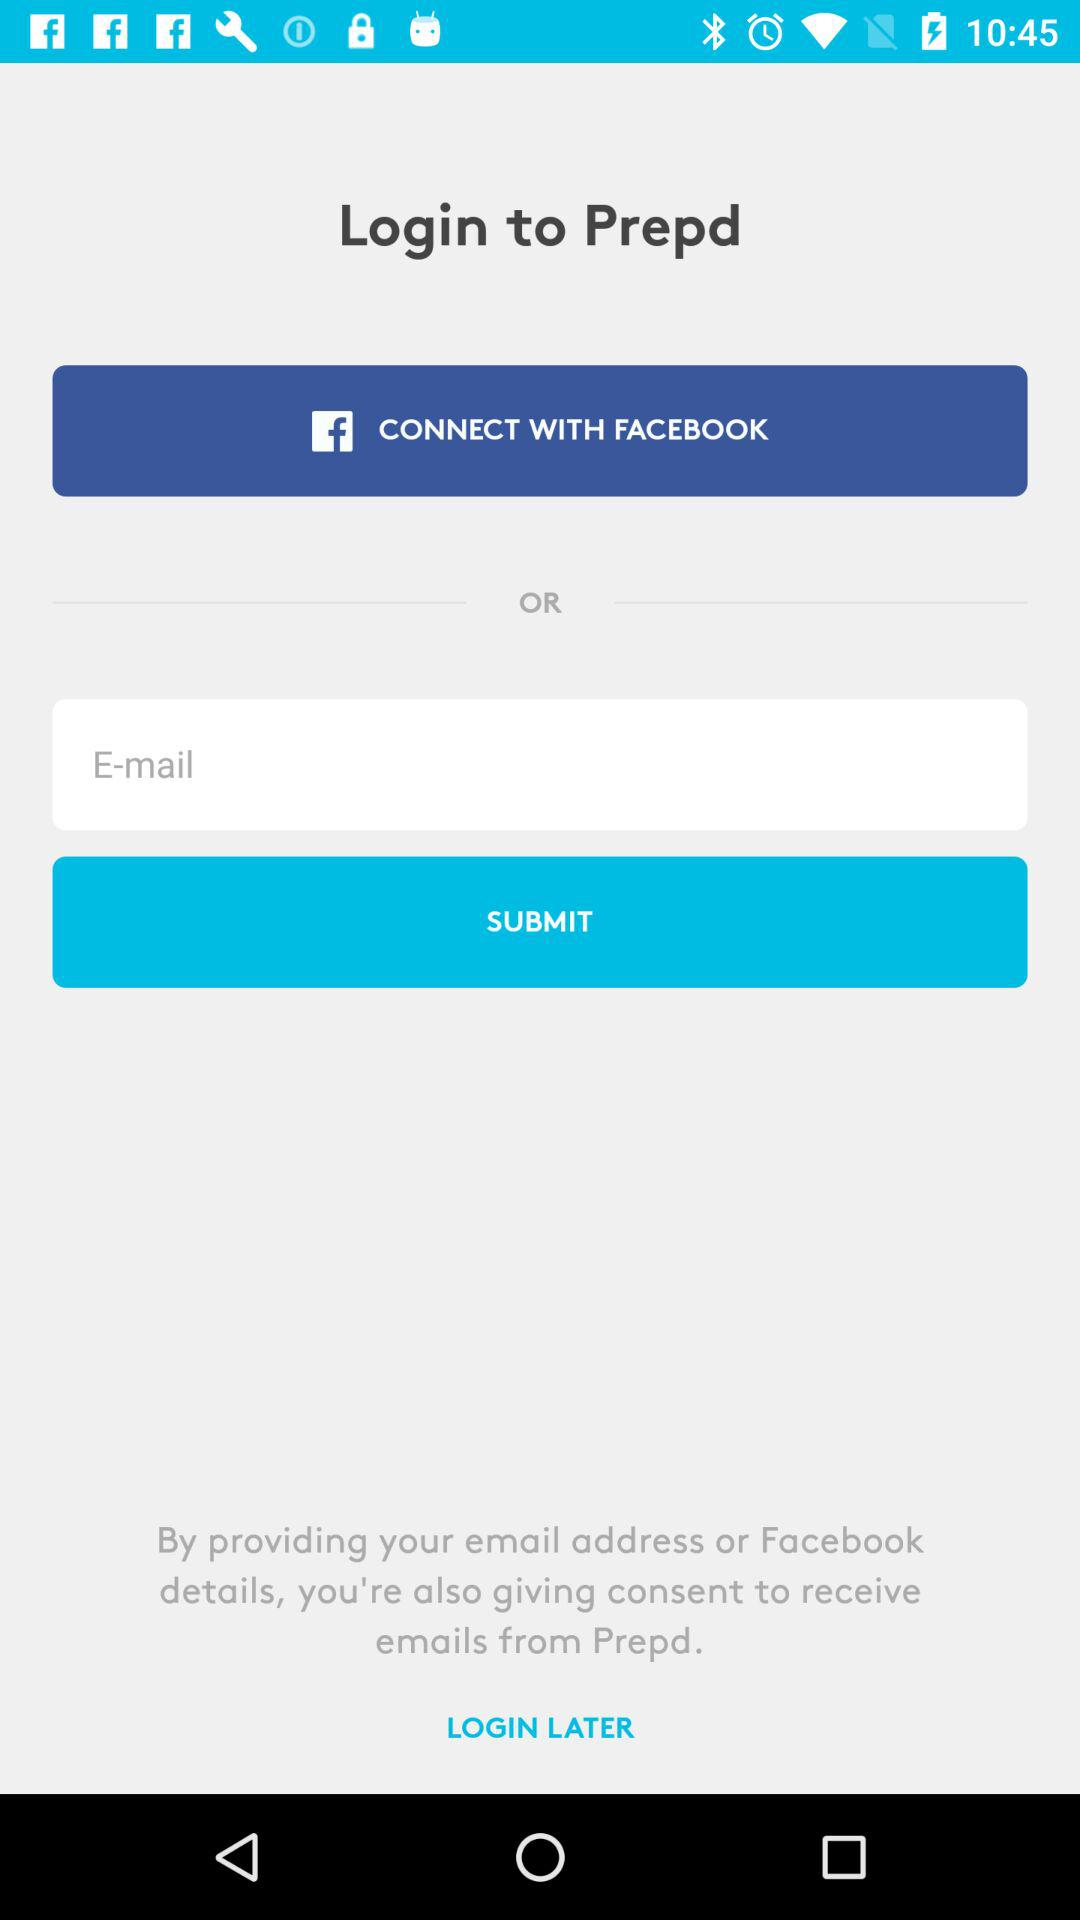How many login options are there?
Answer the question using a single word or phrase. 2 